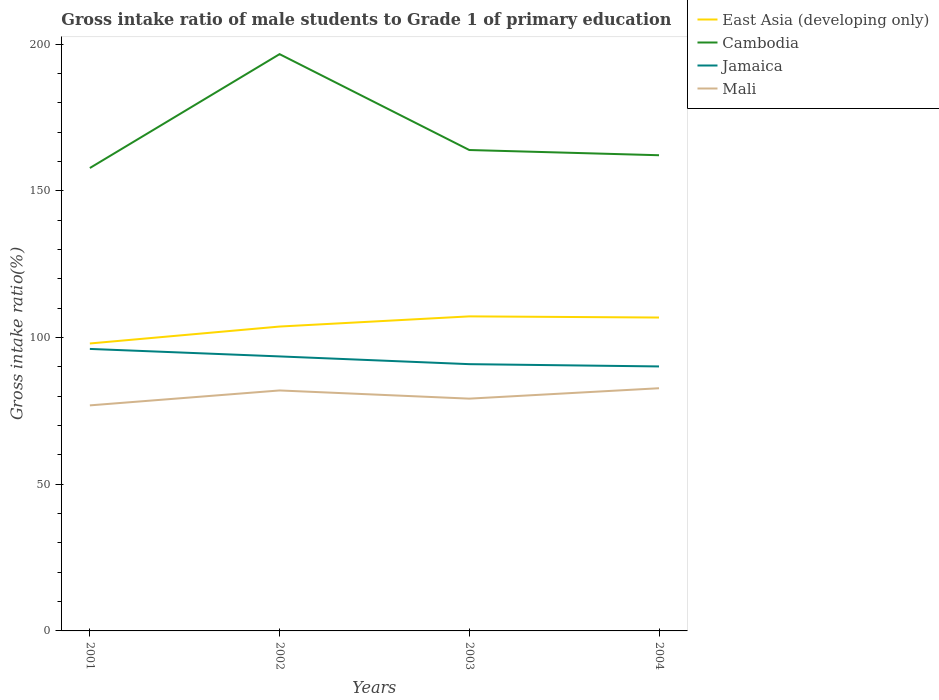Does the line corresponding to Jamaica intersect with the line corresponding to East Asia (developing only)?
Offer a very short reply. No. Across all years, what is the maximum gross intake ratio in Jamaica?
Your answer should be compact. 90.16. In which year was the gross intake ratio in Cambodia maximum?
Your answer should be very brief. 2001. What is the total gross intake ratio in Mali in the graph?
Your answer should be very brief. -0.76. What is the difference between the highest and the second highest gross intake ratio in Cambodia?
Your answer should be compact. 38.82. What is the difference between the highest and the lowest gross intake ratio in Cambodia?
Provide a short and direct response. 1. Is the gross intake ratio in Jamaica strictly greater than the gross intake ratio in East Asia (developing only) over the years?
Keep it short and to the point. Yes. How many lines are there?
Provide a succinct answer. 4. How many years are there in the graph?
Give a very brief answer. 4. What is the difference between two consecutive major ticks on the Y-axis?
Your response must be concise. 50. Are the values on the major ticks of Y-axis written in scientific E-notation?
Ensure brevity in your answer.  No. Does the graph contain any zero values?
Provide a succinct answer. No. Where does the legend appear in the graph?
Your answer should be very brief. Top right. What is the title of the graph?
Give a very brief answer. Gross intake ratio of male students to Grade 1 of primary education. Does "Monaco" appear as one of the legend labels in the graph?
Offer a very short reply. No. What is the label or title of the Y-axis?
Provide a short and direct response. Gross intake ratio(%). What is the Gross intake ratio(%) in East Asia (developing only) in 2001?
Offer a terse response. 97.98. What is the Gross intake ratio(%) in Cambodia in 2001?
Offer a very short reply. 157.79. What is the Gross intake ratio(%) of Jamaica in 2001?
Keep it short and to the point. 96.13. What is the Gross intake ratio(%) of Mali in 2001?
Provide a short and direct response. 76.88. What is the Gross intake ratio(%) of East Asia (developing only) in 2002?
Make the answer very short. 103.76. What is the Gross intake ratio(%) in Cambodia in 2002?
Ensure brevity in your answer.  196.61. What is the Gross intake ratio(%) in Jamaica in 2002?
Offer a terse response. 93.57. What is the Gross intake ratio(%) in Mali in 2002?
Ensure brevity in your answer.  81.97. What is the Gross intake ratio(%) in East Asia (developing only) in 2003?
Provide a succinct answer. 107.22. What is the Gross intake ratio(%) of Cambodia in 2003?
Your response must be concise. 163.93. What is the Gross intake ratio(%) in Jamaica in 2003?
Your answer should be compact. 90.93. What is the Gross intake ratio(%) of Mali in 2003?
Offer a very short reply. 79.18. What is the Gross intake ratio(%) of East Asia (developing only) in 2004?
Your response must be concise. 106.83. What is the Gross intake ratio(%) of Cambodia in 2004?
Ensure brevity in your answer.  162.15. What is the Gross intake ratio(%) of Jamaica in 2004?
Give a very brief answer. 90.16. What is the Gross intake ratio(%) of Mali in 2004?
Give a very brief answer. 82.73. Across all years, what is the maximum Gross intake ratio(%) of East Asia (developing only)?
Provide a short and direct response. 107.22. Across all years, what is the maximum Gross intake ratio(%) in Cambodia?
Your response must be concise. 196.61. Across all years, what is the maximum Gross intake ratio(%) in Jamaica?
Offer a terse response. 96.13. Across all years, what is the maximum Gross intake ratio(%) of Mali?
Give a very brief answer. 82.73. Across all years, what is the minimum Gross intake ratio(%) of East Asia (developing only)?
Provide a succinct answer. 97.98. Across all years, what is the minimum Gross intake ratio(%) of Cambodia?
Your response must be concise. 157.79. Across all years, what is the minimum Gross intake ratio(%) of Jamaica?
Keep it short and to the point. 90.16. Across all years, what is the minimum Gross intake ratio(%) in Mali?
Your answer should be compact. 76.88. What is the total Gross intake ratio(%) of East Asia (developing only) in the graph?
Keep it short and to the point. 415.79. What is the total Gross intake ratio(%) of Cambodia in the graph?
Your answer should be very brief. 680.48. What is the total Gross intake ratio(%) in Jamaica in the graph?
Make the answer very short. 370.79. What is the total Gross intake ratio(%) in Mali in the graph?
Give a very brief answer. 320.76. What is the difference between the Gross intake ratio(%) of East Asia (developing only) in 2001 and that in 2002?
Keep it short and to the point. -5.77. What is the difference between the Gross intake ratio(%) of Cambodia in 2001 and that in 2002?
Provide a succinct answer. -38.82. What is the difference between the Gross intake ratio(%) in Jamaica in 2001 and that in 2002?
Make the answer very short. 2.55. What is the difference between the Gross intake ratio(%) in Mali in 2001 and that in 2002?
Your response must be concise. -5.09. What is the difference between the Gross intake ratio(%) in East Asia (developing only) in 2001 and that in 2003?
Your response must be concise. -9.24. What is the difference between the Gross intake ratio(%) of Cambodia in 2001 and that in 2003?
Offer a very short reply. -6.14. What is the difference between the Gross intake ratio(%) of Jamaica in 2001 and that in 2003?
Your response must be concise. 5.19. What is the difference between the Gross intake ratio(%) in Mali in 2001 and that in 2003?
Your response must be concise. -2.3. What is the difference between the Gross intake ratio(%) of East Asia (developing only) in 2001 and that in 2004?
Provide a succinct answer. -8.84. What is the difference between the Gross intake ratio(%) of Cambodia in 2001 and that in 2004?
Provide a succinct answer. -4.36. What is the difference between the Gross intake ratio(%) of Jamaica in 2001 and that in 2004?
Offer a very short reply. 5.97. What is the difference between the Gross intake ratio(%) in Mali in 2001 and that in 2004?
Your answer should be very brief. -5.84. What is the difference between the Gross intake ratio(%) of East Asia (developing only) in 2002 and that in 2003?
Offer a terse response. -3.47. What is the difference between the Gross intake ratio(%) in Cambodia in 2002 and that in 2003?
Offer a terse response. 32.68. What is the difference between the Gross intake ratio(%) in Jamaica in 2002 and that in 2003?
Offer a very short reply. 2.64. What is the difference between the Gross intake ratio(%) of Mali in 2002 and that in 2003?
Make the answer very short. 2.79. What is the difference between the Gross intake ratio(%) in East Asia (developing only) in 2002 and that in 2004?
Offer a very short reply. -3.07. What is the difference between the Gross intake ratio(%) of Cambodia in 2002 and that in 2004?
Make the answer very short. 34.46. What is the difference between the Gross intake ratio(%) of Jamaica in 2002 and that in 2004?
Offer a terse response. 3.42. What is the difference between the Gross intake ratio(%) in Mali in 2002 and that in 2004?
Your answer should be very brief. -0.76. What is the difference between the Gross intake ratio(%) in East Asia (developing only) in 2003 and that in 2004?
Offer a terse response. 0.39. What is the difference between the Gross intake ratio(%) in Cambodia in 2003 and that in 2004?
Your answer should be compact. 1.78. What is the difference between the Gross intake ratio(%) in Jamaica in 2003 and that in 2004?
Give a very brief answer. 0.78. What is the difference between the Gross intake ratio(%) in Mali in 2003 and that in 2004?
Make the answer very short. -3.55. What is the difference between the Gross intake ratio(%) of East Asia (developing only) in 2001 and the Gross intake ratio(%) of Cambodia in 2002?
Offer a terse response. -98.63. What is the difference between the Gross intake ratio(%) in East Asia (developing only) in 2001 and the Gross intake ratio(%) in Jamaica in 2002?
Offer a very short reply. 4.41. What is the difference between the Gross intake ratio(%) in East Asia (developing only) in 2001 and the Gross intake ratio(%) in Mali in 2002?
Keep it short and to the point. 16.02. What is the difference between the Gross intake ratio(%) in Cambodia in 2001 and the Gross intake ratio(%) in Jamaica in 2002?
Keep it short and to the point. 64.22. What is the difference between the Gross intake ratio(%) of Cambodia in 2001 and the Gross intake ratio(%) of Mali in 2002?
Your response must be concise. 75.82. What is the difference between the Gross intake ratio(%) of Jamaica in 2001 and the Gross intake ratio(%) of Mali in 2002?
Keep it short and to the point. 14.16. What is the difference between the Gross intake ratio(%) of East Asia (developing only) in 2001 and the Gross intake ratio(%) of Cambodia in 2003?
Provide a succinct answer. -65.95. What is the difference between the Gross intake ratio(%) in East Asia (developing only) in 2001 and the Gross intake ratio(%) in Jamaica in 2003?
Ensure brevity in your answer.  7.05. What is the difference between the Gross intake ratio(%) in East Asia (developing only) in 2001 and the Gross intake ratio(%) in Mali in 2003?
Give a very brief answer. 18.8. What is the difference between the Gross intake ratio(%) of Cambodia in 2001 and the Gross intake ratio(%) of Jamaica in 2003?
Provide a short and direct response. 66.86. What is the difference between the Gross intake ratio(%) in Cambodia in 2001 and the Gross intake ratio(%) in Mali in 2003?
Provide a short and direct response. 78.61. What is the difference between the Gross intake ratio(%) in Jamaica in 2001 and the Gross intake ratio(%) in Mali in 2003?
Your response must be concise. 16.95. What is the difference between the Gross intake ratio(%) in East Asia (developing only) in 2001 and the Gross intake ratio(%) in Cambodia in 2004?
Your response must be concise. -64.17. What is the difference between the Gross intake ratio(%) of East Asia (developing only) in 2001 and the Gross intake ratio(%) of Jamaica in 2004?
Your response must be concise. 7.83. What is the difference between the Gross intake ratio(%) of East Asia (developing only) in 2001 and the Gross intake ratio(%) of Mali in 2004?
Give a very brief answer. 15.26. What is the difference between the Gross intake ratio(%) in Cambodia in 2001 and the Gross intake ratio(%) in Jamaica in 2004?
Ensure brevity in your answer.  67.63. What is the difference between the Gross intake ratio(%) of Cambodia in 2001 and the Gross intake ratio(%) of Mali in 2004?
Your answer should be compact. 75.06. What is the difference between the Gross intake ratio(%) in Jamaica in 2001 and the Gross intake ratio(%) in Mali in 2004?
Ensure brevity in your answer.  13.4. What is the difference between the Gross intake ratio(%) in East Asia (developing only) in 2002 and the Gross intake ratio(%) in Cambodia in 2003?
Provide a short and direct response. -60.17. What is the difference between the Gross intake ratio(%) in East Asia (developing only) in 2002 and the Gross intake ratio(%) in Jamaica in 2003?
Your answer should be very brief. 12.82. What is the difference between the Gross intake ratio(%) of East Asia (developing only) in 2002 and the Gross intake ratio(%) of Mali in 2003?
Provide a short and direct response. 24.58. What is the difference between the Gross intake ratio(%) of Cambodia in 2002 and the Gross intake ratio(%) of Jamaica in 2003?
Your answer should be compact. 105.68. What is the difference between the Gross intake ratio(%) in Cambodia in 2002 and the Gross intake ratio(%) in Mali in 2003?
Your answer should be compact. 117.43. What is the difference between the Gross intake ratio(%) of Jamaica in 2002 and the Gross intake ratio(%) of Mali in 2003?
Your answer should be very brief. 14.39. What is the difference between the Gross intake ratio(%) in East Asia (developing only) in 2002 and the Gross intake ratio(%) in Cambodia in 2004?
Offer a very short reply. -58.39. What is the difference between the Gross intake ratio(%) of East Asia (developing only) in 2002 and the Gross intake ratio(%) of Jamaica in 2004?
Keep it short and to the point. 13.6. What is the difference between the Gross intake ratio(%) in East Asia (developing only) in 2002 and the Gross intake ratio(%) in Mali in 2004?
Your response must be concise. 21.03. What is the difference between the Gross intake ratio(%) in Cambodia in 2002 and the Gross intake ratio(%) in Jamaica in 2004?
Give a very brief answer. 106.46. What is the difference between the Gross intake ratio(%) of Cambodia in 2002 and the Gross intake ratio(%) of Mali in 2004?
Your answer should be compact. 113.89. What is the difference between the Gross intake ratio(%) of Jamaica in 2002 and the Gross intake ratio(%) of Mali in 2004?
Give a very brief answer. 10.85. What is the difference between the Gross intake ratio(%) in East Asia (developing only) in 2003 and the Gross intake ratio(%) in Cambodia in 2004?
Provide a succinct answer. -54.93. What is the difference between the Gross intake ratio(%) of East Asia (developing only) in 2003 and the Gross intake ratio(%) of Jamaica in 2004?
Offer a very short reply. 17.07. What is the difference between the Gross intake ratio(%) in East Asia (developing only) in 2003 and the Gross intake ratio(%) in Mali in 2004?
Offer a terse response. 24.5. What is the difference between the Gross intake ratio(%) in Cambodia in 2003 and the Gross intake ratio(%) in Jamaica in 2004?
Make the answer very short. 73.77. What is the difference between the Gross intake ratio(%) of Cambodia in 2003 and the Gross intake ratio(%) of Mali in 2004?
Offer a very short reply. 81.2. What is the difference between the Gross intake ratio(%) of Jamaica in 2003 and the Gross intake ratio(%) of Mali in 2004?
Ensure brevity in your answer.  8.21. What is the average Gross intake ratio(%) of East Asia (developing only) per year?
Make the answer very short. 103.95. What is the average Gross intake ratio(%) in Cambodia per year?
Provide a short and direct response. 170.12. What is the average Gross intake ratio(%) of Jamaica per year?
Offer a terse response. 92.7. What is the average Gross intake ratio(%) in Mali per year?
Offer a very short reply. 80.19. In the year 2001, what is the difference between the Gross intake ratio(%) of East Asia (developing only) and Gross intake ratio(%) of Cambodia?
Your answer should be very brief. -59.81. In the year 2001, what is the difference between the Gross intake ratio(%) of East Asia (developing only) and Gross intake ratio(%) of Jamaica?
Your response must be concise. 1.86. In the year 2001, what is the difference between the Gross intake ratio(%) in East Asia (developing only) and Gross intake ratio(%) in Mali?
Offer a terse response. 21.1. In the year 2001, what is the difference between the Gross intake ratio(%) in Cambodia and Gross intake ratio(%) in Jamaica?
Offer a very short reply. 61.66. In the year 2001, what is the difference between the Gross intake ratio(%) in Cambodia and Gross intake ratio(%) in Mali?
Make the answer very short. 80.91. In the year 2001, what is the difference between the Gross intake ratio(%) in Jamaica and Gross intake ratio(%) in Mali?
Your answer should be compact. 19.24. In the year 2002, what is the difference between the Gross intake ratio(%) of East Asia (developing only) and Gross intake ratio(%) of Cambodia?
Keep it short and to the point. -92.86. In the year 2002, what is the difference between the Gross intake ratio(%) of East Asia (developing only) and Gross intake ratio(%) of Jamaica?
Provide a succinct answer. 10.18. In the year 2002, what is the difference between the Gross intake ratio(%) of East Asia (developing only) and Gross intake ratio(%) of Mali?
Offer a terse response. 21.79. In the year 2002, what is the difference between the Gross intake ratio(%) in Cambodia and Gross intake ratio(%) in Jamaica?
Make the answer very short. 103.04. In the year 2002, what is the difference between the Gross intake ratio(%) in Cambodia and Gross intake ratio(%) in Mali?
Your answer should be compact. 114.64. In the year 2002, what is the difference between the Gross intake ratio(%) in Jamaica and Gross intake ratio(%) in Mali?
Provide a short and direct response. 11.6. In the year 2003, what is the difference between the Gross intake ratio(%) in East Asia (developing only) and Gross intake ratio(%) in Cambodia?
Provide a short and direct response. -56.71. In the year 2003, what is the difference between the Gross intake ratio(%) of East Asia (developing only) and Gross intake ratio(%) of Jamaica?
Your answer should be compact. 16.29. In the year 2003, what is the difference between the Gross intake ratio(%) in East Asia (developing only) and Gross intake ratio(%) in Mali?
Your answer should be compact. 28.04. In the year 2003, what is the difference between the Gross intake ratio(%) of Cambodia and Gross intake ratio(%) of Jamaica?
Ensure brevity in your answer.  73. In the year 2003, what is the difference between the Gross intake ratio(%) in Cambodia and Gross intake ratio(%) in Mali?
Keep it short and to the point. 84.75. In the year 2003, what is the difference between the Gross intake ratio(%) of Jamaica and Gross intake ratio(%) of Mali?
Offer a very short reply. 11.75. In the year 2004, what is the difference between the Gross intake ratio(%) of East Asia (developing only) and Gross intake ratio(%) of Cambodia?
Make the answer very short. -55.32. In the year 2004, what is the difference between the Gross intake ratio(%) of East Asia (developing only) and Gross intake ratio(%) of Jamaica?
Your response must be concise. 16.67. In the year 2004, what is the difference between the Gross intake ratio(%) of East Asia (developing only) and Gross intake ratio(%) of Mali?
Give a very brief answer. 24.1. In the year 2004, what is the difference between the Gross intake ratio(%) in Cambodia and Gross intake ratio(%) in Jamaica?
Keep it short and to the point. 71.99. In the year 2004, what is the difference between the Gross intake ratio(%) in Cambodia and Gross intake ratio(%) in Mali?
Your response must be concise. 79.42. In the year 2004, what is the difference between the Gross intake ratio(%) of Jamaica and Gross intake ratio(%) of Mali?
Your answer should be compact. 7.43. What is the ratio of the Gross intake ratio(%) of East Asia (developing only) in 2001 to that in 2002?
Provide a short and direct response. 0.94. What is the ratio of the Gross intake ratio(%) of Cambodia in 2001 to that in 2002?
Give a very brief answer. 0.8. What is the ratio of the Gross intake ratio(%) in Jamaica in 2001 to that in 2002?
Your response must be concise. 1.03. What is the ratio of the Gross intake ratio(%) in Mali in 2001 to that in 2002?
Offer a very short reply. 0.94. What is the ratio of the Gross intake ratio(%) of East Asia (developing only) in 2001 to that in 2003?
Give a very brief answer. 0.91. What is the ratio of the Gross intake ratio(%) of Cambodia in 2001 to that in 2003?
Your response must be concise. 0.96. What is the ratio of the Gross intake ratio(%) in Jamaica in 2001 to that in 2003?
Your answer should be very brief. 1.06. What is the ratio of the Gross intake ratio(%) of Mali in 2001 to that in 2003?
Make the answer very short. 0.97. What is the ratio of the Gross intake ratio(%) of East Asia (developing only) in 2001 to that in 2004?
Provide a succinct answer. 0.92. What is the ratio of the Gross intake ratio(%) in Cambodia in 2001 to that in 2004?
Provide a short and direct response. 0.97. What is the ratio of the Gross intake ratio(%) of Jamaica in 2001 to that in 2004?
Provide a short and direct response. 1.07. What is the ratio of the Gross intake ratio(%) in Mali in 2001 to that in 2004?
Give a very brief answer. 0.93. What is the ratio of the Gross intake ratio(%) in East Asia (developing only) in 2002 to that in 2003?
Your response must be concise. 0.97. What is the ratio of the Gross intake ratio(%) in Cambodia in 2002 to that in 2003?
Provide a short and direct response. 1.2. What is the ratio of the Gross intake ratio(%) of Mali in 2002 to that in 2003?
Offer a terse response. 1.04. What is the ratio of the Gross intake ratio(%) in East Asia (developing only) in 2002 to that in 2004?
Make the answer very short. 0.97. What is the ratio of the Gross intake ratio(%) in Cambodia in 2002 to that in 2004?
Provide a short and direct response. 1.21. What is the ratio of the Gross intake ratio(%) in Jamaica in 2002 to that in 2004?
Provide a succinct answer. 1.04. What is the ratio of the Gross intake ratio(%) in East Asia (developing only) in 2003 to that in 2004?
Offer a terse response. 1. What is the ratio of the Gross intake ratio(%) of Jamaica in 2003 to that in 2004?
Your answer should be very brief. 1.01. What is the ratio of the Gross intake ratio(%) of Mali in 2003 to that in 2004?
Give a very brief answer. 0.96. What is the difference between the highest and the second highest Gross intake ratio(%) of East Asia (developing only)?
Your response must be concise. 0.39. What is the difference between the highest and the second highest Gross intake ratio(%) in Cambodia?
Your response must be concise. 32.68. What is the difference between the highest and the second highest Gross intake ratio(%) of Jamaica?
Your response must be concise. 2.55. What is the difference between the highest and the second highest Gross intake ratio(%) in Mali?
Provide a short and direct response. 0.76. What is the difference between the highest and the lowest Gross intake ratio(%) in East Asia (developing only)?
Offer a very short reply. 9.24. What is the difference between the highest and the lowest Gross intake ratio(%) in Cambodia?
Keep it short and to the point. 38.82. What is the difference between the highest and the lowest Gross intake ratio(%) of Jamaica?
Give a very brief answer. 5.97. What is the difference between the highest and the lowest Gross intake ratio(%) of Mali?
Offer a terse response. 5.84. 